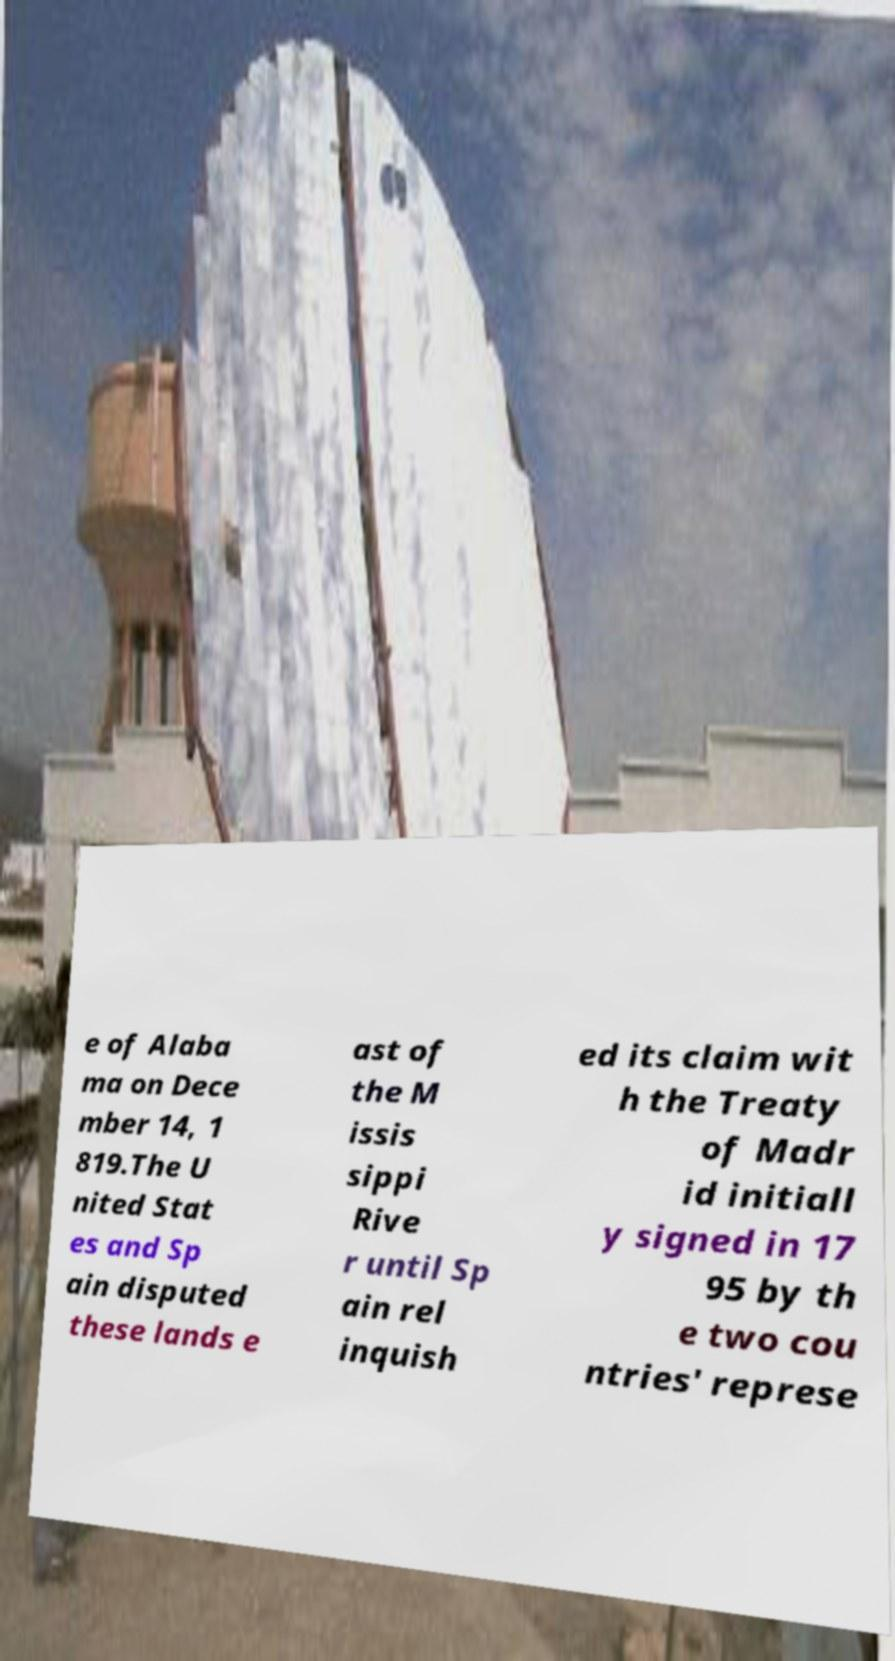Could you assist in decoding the text presented in this image and type it out clearly? e of Alaba ma on Dece mber 14, 1 819.The U nited Stat es and Sp ain disputed these lands e ast of the M issis sippi Rive r until Sp ain rel inquish ed its claim wit h the Treaty of Madr id initiall y signed in 17 95 by th e two cou ntries' represe 